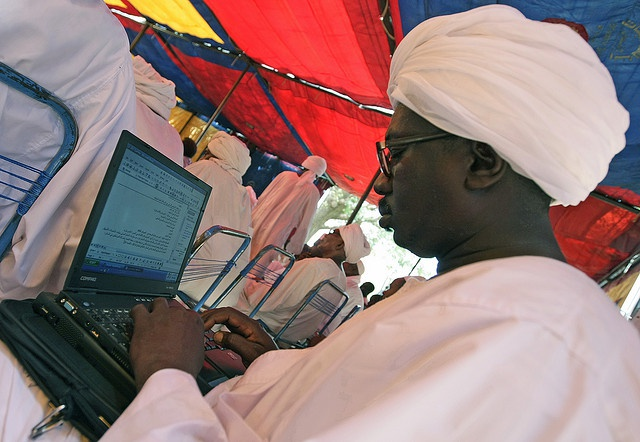Describe the objects in this image and their specific colors. I can see people in lightgray, darkgray, and black tones, people in lightgray, darkgray, and gray tones, laptop in lightgray, black, teal, and blue tones, chair in lightgray, gray, blue, and navy tones, and people in lightgray, darkgray, gray, and tan tones in this image. 